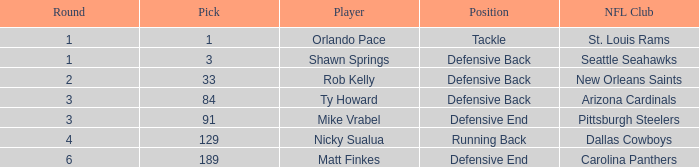Would you be able to parse every entry in this table? {'header': ['Round', 'Pick', 'Player', 'Position', 'NFL Club'], 'rows': [['1', '1', 'Orlando Pace', 'Tackle', 'St. Louis Rams'], ['1', '3', 'Shawn Springs', 'Defensive Back', 'Seattle Seahawks'], ['2', '33', 'Rob Kelly', 'Defensive Back', 'New Orleans Saints'], ['3', '84', 'Ty Howard', 'Defensive Back', 'Arizona Cardinals'], ['3', '91', 'Mike Vrabel', 'Defensive End', 'Pittsburgh Steelers'], ['4', '129', 'Nicky Sualua', 'Running Back', 'Dallas Cowboys'], ['6', '189', 'Matt Finkes', 'Defensive End', 'Carolina Panthers']]} What round has a pick less than 189, with arizona cardinals as the NFL club? 3.0. 